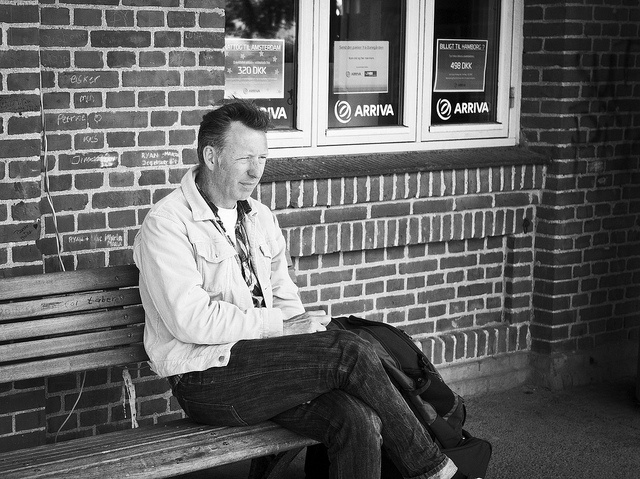Describe the objects in this image and their specific colors. I can see people in gray, black, lightgray, and darkgray tones, bench in gray, black, darkgray, and lightgray tones, backpack in gray, black, and gainsboro tones, and suitcase in black, gray, and darkgray tones in this image. 